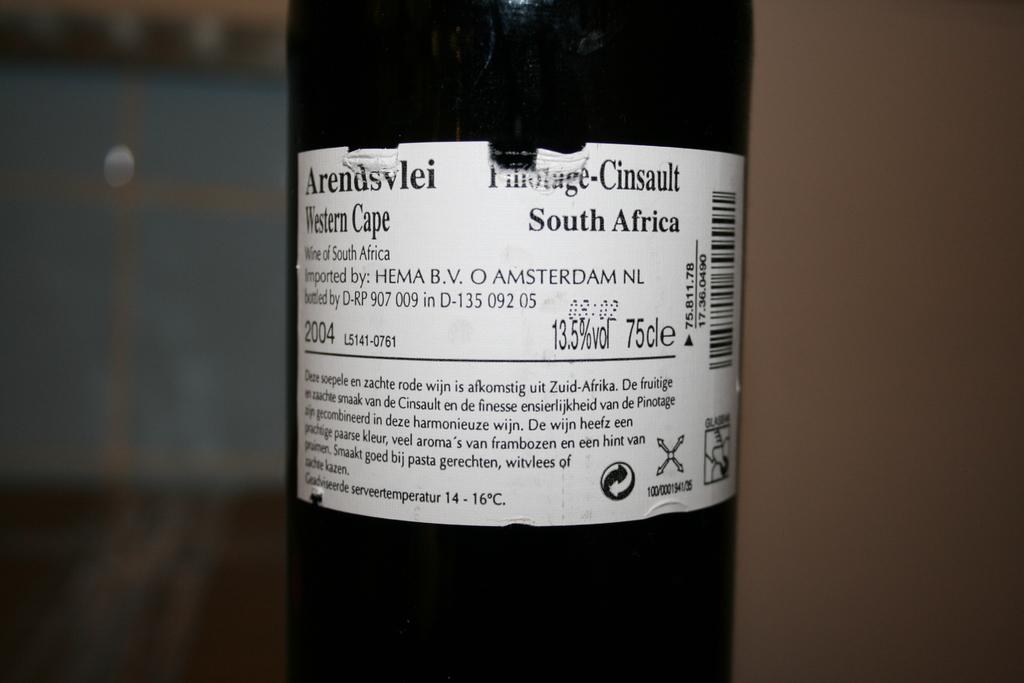<image>
Give a short and clear explanation of the subsequent image. 2004 bottle of western cape wine of south africa 